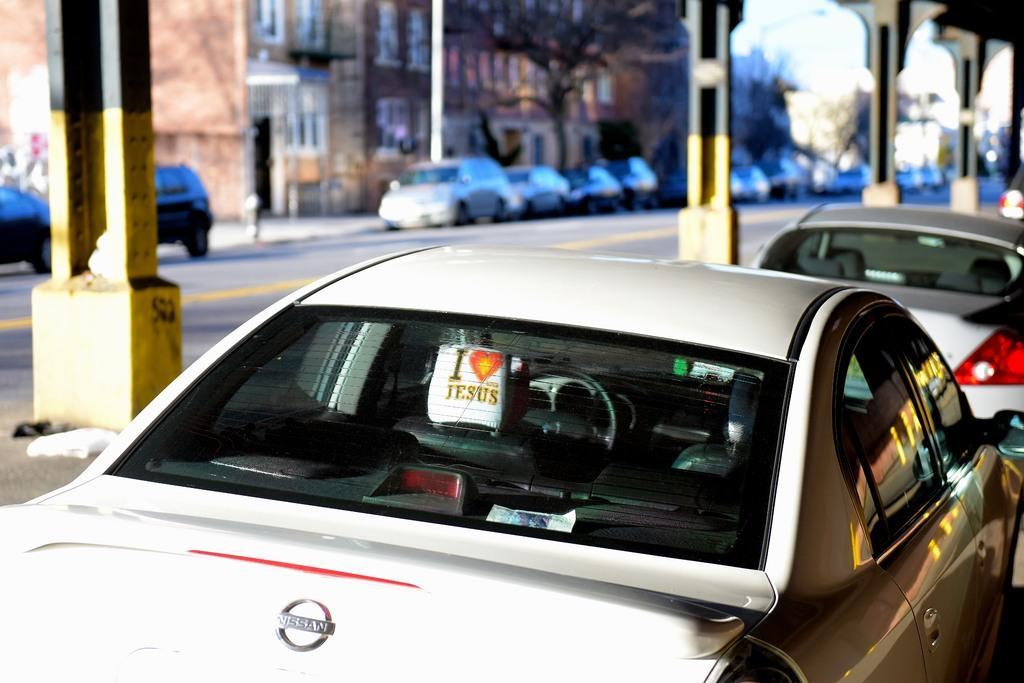In one or two sentences, can you explain what this image depicts? In this image there are cars. In the center there are pillars. In the background there are trees and there are buildings. 